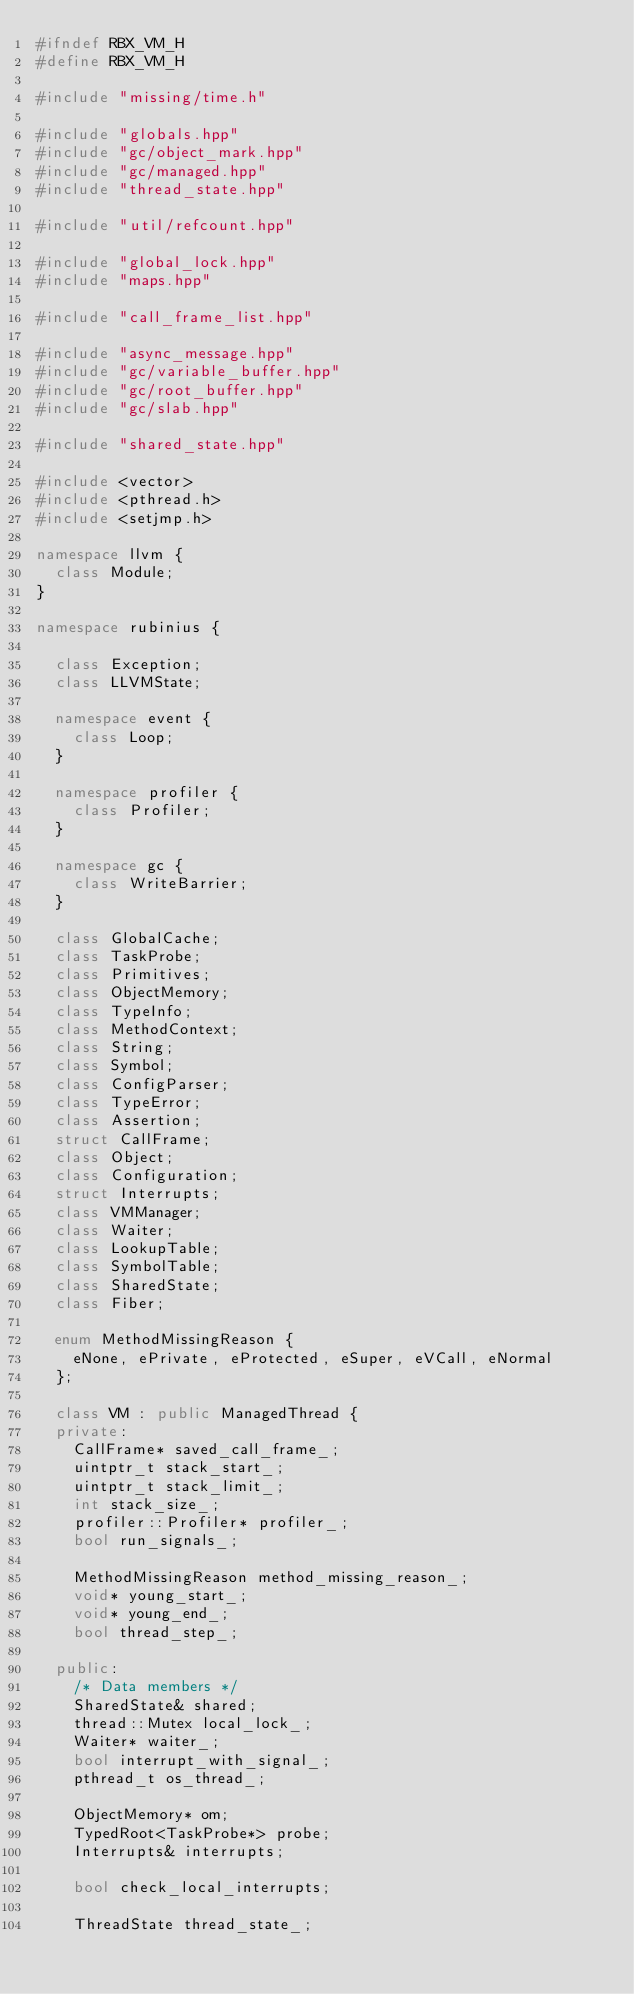Convert code to text. <code><loc_0><loc_0><loc_500><loc_500><_C++_>#ifndef RBX_VM_H
#define RBX_VM_H

#include "missing/time.h"

#include "globals.hpp"
#include "gc/object_mark.hpp"
#include "gc/managed.hpp"
#include "thread_state.hpp"

#include "util/refcount.hpp"

#include "global_lock.hpp"
#include "maps.hpp"

#include "call_frame_list.hpp"

#include "async_message.hpp"
#include "gc/variable_buffer.hpp"
#include "gc/root_buffer.hpp"
#include "gc/slab.hpp"

#include "shared_state.hpp"

#include <vector>
#include <pthread.h>
#include <setjmp.h>

namespace llvm {
  class Module;
}

namespace rubinius {

  class Exception;
  class LLVMState;

  namespace event {
    class Loop;
  }

  namespace profiler {
    class Profiler;
  }

  namespace gc {
    class WriteBarrier;
  }

  class GlobalCache;
  class TaskProbe;
  class Primitives;
  class ObjectMemory;
  class TypeInfo;
  class MethodContext;
  class String;
  class Symbol;
  class ConfigParser;
  class TypeError;
  class Assertion;
  struct CallFrame;
  class Object;
  class Configuration;
  struct Interrupts;
  class VMManager;
  class Waiter;
  class LookupTable;
  class SymbolTable;
  class SharedState;
  class Fiber;

  enum MethodMissingReason {
    eNone, ePrivate, eProtected, eSuper, eVCall, eNormal
  };

  class VM : public ManagedThread {
  private:
    CallFrame* saved_call_frame_;
    uintptr_t stack_start_;
    uintptr_t stack_limit_;
    int stack_size_;
    profiler::Profiler* profiler_;
    bool run_signals_;

    MethodMissingReason method_missing_reason_;
    void* young_start_;
    void* young_end_;
    bool thread_step_;

  public:
    /* Data members */
    SharedState& shared;
    thread::Mutex local_lock_;
    Waiter* waiter_;
    bool interrupt_with_signal_;
    pthread_t os_thread_;

    ObjectMemory* om;
    TypedRoot<TaskProbe*> probe;
    Interrupts& interrupts;

    bool check_local_interrupts;

    ThreadState thread_state_;
</code> 